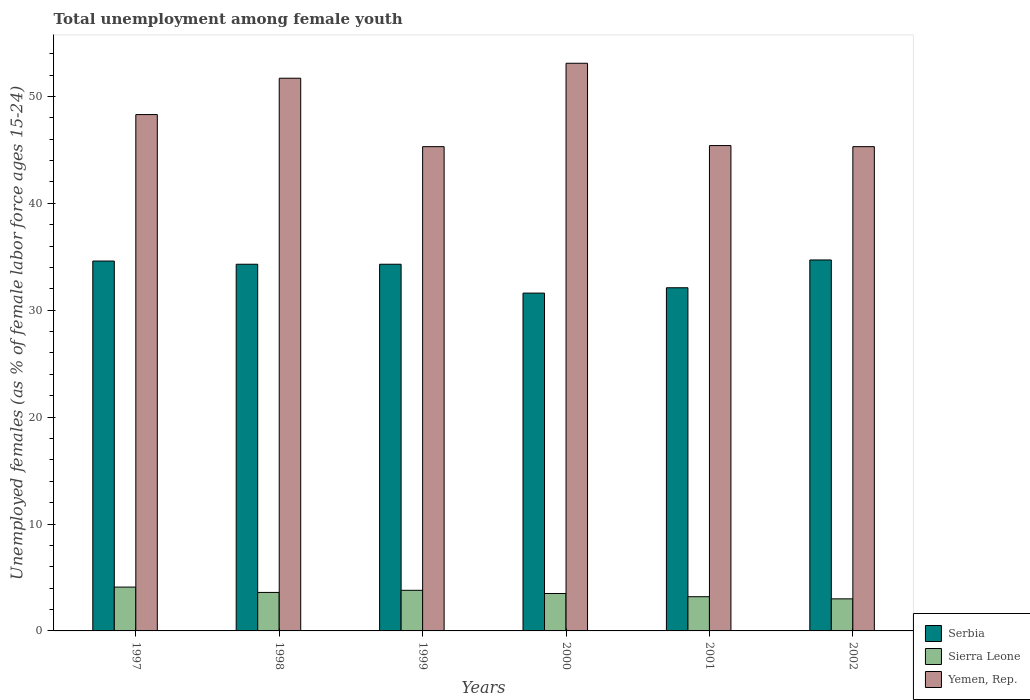Are the number of bars on each tick of the X-axis equal?
Give a very brief answer. Yes. How many bars are there on the 5th tick from the right?
Keep it short and to the point. 3. What is the label of the 5th group of bars from the left?
Make the answer very short. 2001. In how many cases, is the number of bars for a given year not equal to the number of legend labels?
Provide a succinct answer. 0. What is the percentage of unemployed females in in Sierra Leone in 2001?
Your answer should be compact. 3.2. Across all years, what is the maximum percentage of unemployed females in in Sierra Leone?
Your response must be concise. 4.1. Across all years, what is the minimum percentage of unemployed females in in Serbia?
Make the answer very short. 31.6. In which year was the percentage of unemployed females in in Serbia maximum?
Offer a very short reply. 2002. What is the total percentage of unemployed females in in Yemen, Rep. in the graph?
Give a very brief answer. 289.1. What is the difference between the percentage of unemployed females in in Sierra Leone in 1998 and that in 2000?
Offer a very short reply. 0.1. What is the difference between the percentage of unemployed females in in Serbia in 1997 and the percentage of unemployed females in in Yemen, Rep. in 1999?
Give a very brief answer. -10.7. What is the average percentage of unemployed females in in Yemen, Rep. per year?
Make the answer very short. 48.18. In the year 2002, what is the difference between the percentage of unemployed females in in Serbia and percentage of unemployed females in in Sierra Leone?
Offer a terse response. 31.7. In how many years, is the percentage of unemployed females in in Sierra Leone greater than 32 %?
Offer a terse response. 0. What is the ratio of the percentage of unemployed females in in Sierra Leone in 1997 to that in 1998?
Keep it short and to the point. 1.14. Is the difference between the percentage of unemployed females in in Serbia in 1999 and 2001 greater than the difference between the percentage of unemployed females in in Sierra Leone in 1999 and 2001?
Your answer should be very brief. Yes. What is the difference between the highest and the second highest percentage of unemployed females in in Sierra Leone?
Provide a succinct answer. 0.3. What is the difference between the highest and the lowest percentage of unemployed females in in Yemen, Rep.?
Your response must be concise. 7.8. In how many years, is the percentage of unemployed females in in Yemen, Rep. greater than the average percentage of unemployed females in in Yemen, Rep. taken over all years?
Keep it short and to the point. 3. What does the 3rd bar from the left in 2001 represents?
Make the answer very short. Yemen, Rep. What does the 2nd bar from the right in 1998 represents?
Offer a very short reply. Sierra Leone. Is it the case that in every year, the sum of the percentage of unemployed females in in Sierra Leone and percentage of unemployed females in in Serbia is greater than the percentage of unemployed females in in Yemen, Rep.?
Give a very brief answer. No. Are the values on the major ticks of Y-axis written in scientific E-notation?
Offer a terse response. No. Does the graph contain any zero values?
Make the answer very short. No. How are the legend labels stacked?
Ensure brevity in your answer.  Vertical. What is the title of the graph?
Offer a terse response. Total unemployment among female youth. Does "Tajikistan" appear as one of the legend labels in the graph?
Make the answer very short. No. What is the label or title of the X-axis?
Give a very brief answer. Years. What is the label or title of the Y-axis?
Offer a terse response. Unemployed females (as % of female labor force ages 15-24). What is the Unemployed females (as % of female labor force ages 15-24) in Serbia in 1997?
Give a very brief answer. 34.6. What is the Unemployed females (as % of female labor force ages 15-24) in Sierra Leone in 1997?
Your response must be concise. 4.1. What is the Unemployed females (as % of female labor force ages 15-24) of Yemen, Rep. in 1997?
Ensure brevity in your answer.  48.3. What is the Unemployed females (as % of female labor force ages 15-24) in Serbia in 1998?
Ensure brevity in your answer.  34.3. What is the Unemployed females (as % of female labor force ages 15-24) in Sierra Leone in 1998?
Your answer should be compact. 3.6. What is the Unemployed females (as % of female labor force ages 15-24) of Yemen, Rep. in 1998?
Provide a succinct answer. 51.7. What is the Unemployed females (as % of female labor force ages 15-24) of Serbia in 1999?
Offer a terse response. 34.3. What is the Unemployed females (as % of female labor force ages 15-24) of Sierra Leone in 1999?
Ensure brevity in your answer.  3.8. What is the Unemployed females (as % of female labor force ages 15-24) of Yemen, Rep. in 1999?
Provide a short and direct response. 45.3. What is the Unemployed females (as % of female labor force ages 15-24) of Serbia in 2000?
Make the answer very short. 31.6. What is the Unemployed females (as % of female labor force ages 15-24) in Sierra Leone in 2000?
Offer a terse response. 3.5. What is the Unemployed females (as % of female labor force ages 15-24) in Yemen, Rep. in 2000?
Offer a terse response. 53.1. What is the Unemployed females (as % of female labor force ages 15-24) in Serbia in 2001?
Give a very brief answer. 32.1. What is the Unemployed females (as % of female labor force ages 15-24) in Sierra Leone in 2001?
Keep it short and to the point. 3.2. What is the Unemployed females (as % of female labor force ages 15-24) of Yemen, Rep. in 2001?
Offer a terse response. 45.4. What is the Unemployed females (as % of female labor force ages 15-24) of Serbia in 2002?
Keep it short and to the point. 34.7. What is the Unemployed females (as % of female labor force ages 15-24) of Yemen, Rep. in 2002?
Your answer should be very brief. 45.3. Across all years, what is the maximum Unemployed females (as % of female labor force ages 15-24) in Serbia?
Offer a very short reply. 34.7. Across all years, what is the maximum Unemployed females (as % of female labor force ages 15-24) of Sierra Leone?
Offer a terse response. 4.1. Across all years, what is the maximum Unemployed females (as % of female labor force ages 15-24) in Yemen, Rep.?
Your response must be concise. 53.1. Across all years, what is the minimum Unemployed females (as % of female labor force ages 15-24) in Serbia?
Your answer should be very brief. 31.6. Across all years, what is the minimum Unemployed females (as % of female labor force ages 15-24) in Sierra Leone?
Ensure brevity in your answer.  3. Across all years, what is the minimum Unemployed females (as % of female labor force ages 15-24) in Yemen, Rep.?
Keep it short and to the point. 45.3. What is the total Unemployed females (as % of female labor force ages 15-24) in Serbia in the graph?
Ensure brevity in your answer.  201.6. What is the total Unemployed females (as % of female labor force ages 15-24) of Sierra Leone in the graph?
Your response must be concise. 21.2. What is the total Unemployed females (as % of female labor force ages 15-24) of Yemen, Rep. in the graph?
Your answer should be very brief. 289.1. What is the difference between the Unemployed females (as % of female labor force ages 15-24) of Sierra Leone in 1997 and that in 1998?
Your answer should be very brief. 0.5. What is the difference between the Unemployed females (as % of female labor force ages 15-24) in Yemen, Rep. in 1997 and that in 1998?
Give a very brief answer. -3.4. What is the difference between the Unemployed females (as % of female labor force ages 15-24) in Serbia in 1997 and that in 1999?
Provide a succinct answer. 0.3. What is the difference between the Unemployed females (as % of female labor force ages 15-24) in Sierra Leone in 1997 and that in 1999?
Make the answer very short. 0.3. What is the difference between the Unemployed females (as % of female labor force ages 15-24) of Yemen, Rep. in 1997 and that in 1999?
Provide a short and direct response. 3. What is the difference between the Unemployed females (as % of female labor force ages 15-24) of Yemen, Rep. in 1997 and that in 2000?
Your answer should be compact. -4.8. What is the difference between the Unemployed females (as % of female labor force ages 15-24) in Yemen, Rep. in 1997 and that in 2001?
Offer a very short reply. 2.9. What is the difference between the Unemployed females (as % of female labor force ages 15-24) of Serbia in 1997 and that in 2002?
Keep it short and to the point. -0.1. What is the difference between the Unemployed females (as % of female labor force ages 15-24) of Sierra Leone in 1997 and that in 2002?
Make the answer very short. 1.1. What is the difference between the Unemployed females (as % of female labor force ages 15-24) in Yemen, Rep. in 1997 and that in 2002?
Give a very brief answer. 3. What is the difference between the Unemployed females (as % of female labor force ages 15-24) of Serbia in 1998 and that in 1999?
Provide a short and direct response. 0. What is the difference between the Unemployed females (as % of female labor force ages 15-24) in Sierra Leone in 1998 and that in 1999?
Provide a succinct answer. -0.2. What is the difference between the Unemployed females (as % of female labor force ages 15-24) of Yemen, Rep. in 1998 and that in 1999?
Ensure brevity in your answer.  6.4. What is the difference between the Unemployed females (as % of female labor force ages 15-24) in Sierra Leone in 1998 and that in 2000?
Offer a terse response. 0.1. What is the difference between the Unemployed females (as % of female labor force ages 15-24) in Yemen, Rep. in 1998 and that in 2000?
Ensure brevity in your answer.  -1.4. What is the difference between the Unemployed females (as % of female labor force ages 15-24) in Serbia in 1998 and that in 2002?
Your response must be concise. -0.4. What is the difference between the Unemployed females (as % of female labor force ages 15-24) of Sierra Leone in 1999 and that in 2000?
Make the answer very short. 0.3. What is the difference between the Unemployed females (as % of female labor force ages 15-24) in Serbia in 1999 and that in 2001?
Provide a succinct answer. 2.2. What is the difference between the Unemployed females (as % of female labor force ages 15-24) of Sierra Leone in 1999 and that in 2001?
Your answer should be compact. 0.6. What is the difference between the Unemployed females (as % of female labor force ages 15-24) of Yemen, Rep. in 1999 and that in 2002?
Your answer should be compact. 0. What is the difference between the Unemployed females (as % of female labor force ages 15-24) of Sierra Leone in 2000 and that in 2001?
Provide a succinct answer. 0.3. What is the difference between the Unemployed females (as % of female labor force ages 15-24) of Yemen, Rep. in 2000 and that in 2001?
Offer a terse response. 7.7. What is the difference between the Unemployed females (as % of female labor force ages 15-24) of Yemen, Rep. in 2000 and that in 2002?
Keep it short and to the point. 7.8. What is the difference between the Unemployed females (as % of female labor force ages 15-24) in Serbia in 1997 and the Unemployed females (as % of female labor force ages 15-24) in Yemen, Rep. in 1998?
Give a very brief answer. -17.1. What is the difference between the Unemployed females (as % of female labor force ages 15-24) in Sierra Leone in 1997 and the Unemployed females (as % of female labor force ages 15-24) in Yemen, Rep. in 1998?
Your answer should be compact. -47.6. What is the difference between the Unemployed females (as % of female labor force ages 15-24) in Serbia in 1997 and the Unemployed females (as % of female labor force ages 15-24) in Sierra Leone in 1999?
Your response must be concise. 30.8. What is the difference between the Unemployed females (as % of female labor force ages 15-24) of Sierra Leone in 1997 and the Unemployed females (as % of female labor force ages 15-24) of Yemen, Rep. in 1999?
Provide a short and direct response. -41.2. What is the difference between the Unemployed females (as % of female labor force ages 15-24) of Serbia in 1997 and the Unemployed females (as % of female labor force ages 15-24) of Sierra Leone in 2000?
Your answer should be very brief. 31.1. What is the difference between the Unemployed females (as % of female labor force ages 15-24) of Serbia in 1997 and the Unemployed females (as % of female labor force ages 15-24) of Yemen, Rep. in 2000?
Offer a very short reply. -18.5. What is the difference between the Unemployed females (as % of female labor force ages 15-24) of Sierra Leone in 1997 and the Unemployed females (as % of female labor force ages 15-24) of Yemen, Rep. in 2000?
Keep it short and to the point. -49. What is the difference between the Unemployed females (as % of female labor force ages 15-24) in Serbia in 1997 and the Unemployed females (as % of female labor force ages 15-24) in Sierra Leone in 2001?
Keep it short and to the point. 31.4. What is the difference between the Unemployed females (as % of female labor force ages 15-24) in Sierra Leone in 1997 and the Unemployed females (as % of female labor force ages 15-24) in Yemen, Rep. in 2001?
Ensure brevity in your answer.  -41.3. What is the difference between the Unemployed females (as % of female labor force ages 15-24) in Serbia in 1997 and the Unemployed females (as % of female labor force ages 15-24) in Sierra Leone in 2002?
Your response must be concise. 31.6. What is the difference between the Unemployed females (as % of female labor force ages 15-24) of Sierra Leone in 1997 and the Unemployed females (as % of female labor force ages 15-24) of Yemen, Rep. in 2002?
Your answer should be compact. -41.2. What is the difference between the Unemployed females (as % of female labor force ages 15-24) of Serbia in 1998 and the Unemployed females (as % of female labor force ages 15-24) of Sierra Leone in 1999?
Your answer should be very brief. 30.5. What is the difference between the Unemployed females (as % of female labor force ages 15-24) in Serbia in 1998 and the Unemployed females (as % of female labor force ages 15-24) in Yemen, Rep. in 1999?
Your answer should be very brief. -11. What is the difference between the Unemployed females (as % of female labor force ages 15-24) of Sierra Leone in 1998 and the Unemployed females (as % of female labor force ages 15-24) of Yemen, Rep. in 1999?
Give a very brief answer. -41.7. What is the difference between the Unemployed females (as % of female labor force ages 15-24) in Serbia in 1998 and the Unemployed females (as % of female labor force ages 15-24) in Sierra Leone in 2000?
Keep it short and to the point. 30.8. What is the difference between the Unemployed females (as % of female labor force ages 15-24) in Serbia in 1998 and the Unemployed females (as % of female labor force ages 15-24) in Yemen, Rep. in 2000?
Your response must be concise. -18.8. What is the difference between the Unemployed females (as % of female labor force ages 15-24) of Sierra Leone in 1998 and the Unemployed females (as % of female labor force ages 15-24) of Yemen, Rep. in 2000?
Keep it short and to the point. -49.5. What is the difference between the Unemployed females (as % of female labor force ages 15-24) in Serbia in 1998 and the Unemployed females (as % of female labor force ages 15-24) in Sierra Leone in 2001?
Your response must be concise. 31.1. What is the difference between the Unemployed females (as % of female labor force ages 15-24) of Sierra Leone in 1998 and the Unemployed females (as % of female labor force ages 15-24) of Yemen, Rep. in 2001?
Provide a succinct answer. -41.8. What is the difference between the Unemployed females (as % of female labor force ages 15-24) of Serbia in 1998 and the Unemployed females (as % of female labor force ages 15-24) of Sierra Leone in 2002?
Offer a very short reply. 31.3. What is the difference between the Unemployed females (as % of female labor force ages 15-24) in Serbia in 1998 and the Unemployed females (as % of female labor force ages 15-24) in Yemen, Rep. in 2002?
Give a very brief answer. -11. What is the difference between the Unemployed females (as % of female labor force ages 15-24) in Sierra Leone in 1998 and the Unemployed females (as % of female labor force ages 15-24) in Yemen, Rep. in 2002?
Your answer should be compact. -41.7. What is the difference between the Unemployed females (as % of female labor force ages 15-24) of Serbia in 1999 and the Unemployed females (as % of female labor force ages 15-24) of Sierra Leone in 2000?
Provide a short and direct response. 30.8. What is the difference between the Unemployed females (as % of female labor force ages 15-24) in Serbia in 1999 and the Unemployed females (as % of female labor force ages 15-24) in Yemen, Rep. in 2000?
Provide a succinct answer. -18.8. What is the difference between the Unemployed females (as % of female labor force ages 15-24) of Sierra Leone in 1999 and the Unemployed females (as % of female labor force ages 15-24) of Yemen, Rep. in 2000?
Your response must be concise. -49.3. What is the difference between the Unemployed females (as % of female labor force ages 15-24) in Serbia in 1999 and the Unemployed females (as % of female labor force ages 15-24) in Sierra Leone in 2001?
Provide a short and direct response. 31.1. What is the difference between the Unemployed females (as % of female labor force ages 15-24) in Serbia in 1999 and the Unemployed females (as % of female labor force ages 15-24) in Yemen, Rep. in 2001?
Offer a terse response. -11.1. What is the difference between the Unemployed females (as % of female labor force ages 15-24) of Sierra Leone in 1999 and the Unemployed females (as % of female labor force ages 15-24) of Yemen, Rep. in 2001?
Give a very brief answer. -41.6. What is the difference between the Unemployed females (as % of female labor force ages 15-24) of Serbia in 1999 and the Unemployed females (as % of female labor force ages 15-24) of Sierra Leone in 2002?
Provide a short and direct response. 31.3. What is the difference between the Unemployed females (as % of female labor force ages 15-24) in Sierra Leone in 1999 and the Unemployed females (as % of female labor force ages 15-24) in Yemen, Rep. in 2002?
Ensure brevity in your answer.  -41.5. What is the difference between the Unemployed females (as % of female labor force ages 15-24) in Serbia in 2000 and the Unemployed females (as % of female labor force ages 15-24) in Sierra Leone in 2001?
Your answer should be compact. 28.4. What is the difference between the Unemployed females (as % of female labor force ages 15-24) of Serbia in 2000 and the Unemployed females (as % of female labor force ages 15-24) of Yemen, Rep. in 2001?
Your answer should be compact. -13.8. What is the difference between the Unemployed females (as % of female labor force ages 15-24) of Sierra Leone in 2000 and the Unemployed females (as % of female labor force ages 15-24) of Yemen, Rep. in 2001?
Ensure brevity in your answer.  -41.9. What is the difference between the Unemployed females (as % of female labor force ages 15-24) of Serbia in 2000 and the Unemployed females (as % of female labor force ages 15-24) of Sierra Leone in 2002?
Your answer should be very brief. 28.6. What is the difference between the Unemployed females (as % of female labor force ages 15-24) in Serbia in 2000 and the Unemployed females (as % of female labor force ages 15-24) in Yemen, Rep. in 2002?
Offer a very short reply. -13.7. What is the difference between the Unemployed females (as % of female labor force ages 15-24) of Sierra Leone in 2000 and the Unemployed females (as % of female labor force ages 15-24) of Yemen, Rep. in 2002?
Your response must be concise. -41.8. What is the difference between the Unemployed females (as % of female labor force ages 15-24) in Serbia in 2001 and the Unemployed females (as % of female labor force ages 15-24) in Sierra Leone in 2002?
Provide a succinct answer. 29.1. What is the difference between the Unemployed females (as % of female labor force ages 15-24) in Serbia in 2001 and the Unemployed females (as % of female labor force ages 15-24) in Yemen, Rep. in 2002?
Ensure brevity in your answer.  -13.2. What is the difference between the Unemployed females (as % of female labor force ages 15-24) of Sierra Leone in 2001 and the Unemployed females (as % of female labor force ages 15-24) of Yemen, Rep. in 2002?
Your answer should be compact. -42.1. What is the average Unemployed females (as % of female labor force ages 15-24) in Serbia per year?
Make the answer very short. 33.6. What is the average Unemployed females (as % of female labor force ages 15-24) in Sierra Leone per year?
Keep it short and to the point. 3.53. What is the average Unemployed females (as % of female labor force ages 15-24) of Yemen, Rep. per year?
Keep it short and to the point. 48.18. In the year 1997, what is the difference between the Unemployed females (as % of female labor force ages 15-24) of Serbia and Unemployed females (as % of female labor force ages 15-24) of Sierra Leone?
Your answer should be compact. 30.5. In the year 1997, what is the difference between the Unemployed females (as % of female labor force ages 15-24) of Serbia and Unemployed females (as % of female labor force ages 15-24) of Yemen, Rep.?
Give a very brief answer. -13.7. In the year 1997, what is the difference between the Unemployed females (as % of female labor force ages 15-24) of Sierra Leone and Unemployed females (as % of female labor force ages 15-24) of Yemen, Rep.?
Your answer should be very brief. -44.2. In the year 1998, what is the difference between the Unemployed females (as % of female labor force ages 15-24) of Serbia and Unemployed females (as % of female labor force ages 15-24) of Sierra Leone?
Offer a very short reply. 30.7. In the year 1998, what is the difference between the Unemployed females (as % of female labor force ages 15-24) in Serbia and Unemployed females (as % of female labor force ages 15-24) in Yemen, Rep.?
Your answer should be very brief. -17.4. In the year 1998, what is the difference between the Unemployed females (as % of female labor force ages 15-24) in Sierra Leone and Unemployed females (as % of female labor force ages 15-24) in Yemen, Rep.?
Give a very brief answer. -48.1. In the year 1999, what is the difference between the Unemployed females (as % of female labor force ages 15-24) of Serbia and Unemployed females (as % of female labor force ages 15-24) of Sierra Leone?
Ensure brevity in your answer.  30.5. In the year 1999, what is the difference between the Unemployed females (as % of female labor force ages 15-24) in Serbia and Unemployed females (as % of female labor force ages 15-24) in Yemen, Rep.?
Provide a succinct answer. -11. In the year 1999, what is the difference between the Unemployed females (as % of female labor force ages 15-24) in Sierra Leone and Unemployed females (as % of female labor force ages 15-24) in Yemen, Rep.?
Provide a short and direct response. -41.5. In the year 2000, what is the difference between the Unemployed females (as % of female labor force ages 15-24) in Serbia and Unemployed females (as % of female labor force ages 15-24) in Sierra Leone?
Offer a terse response. 28.1. In the year 2000, what is the difference between the Unemployed females (as % of female labor force ages 15-24) in Serbia and Unemployed females (as % of female labor force ages 15-24) in Yemen, Rep.?
Keep it short and to the point. -21.5. In the year 2000, what is the difference between the Unemployed females (as % of female labor force ages 15-24) in Sierra Leone and Unemployed females (as % of female labor force ages 15-24) in Yemen, Rep.?
Provide a short and direct response. -49.6. In the year 2001, what is the difference between the Unemployed females (as % of female labor force ages 15-24) of Serbia and Unemployed females (as % of female labor force ages 15-24) of Sierra Leone?
Make the answer very short. 28.9. In the year 2001, what is the difference between the Unemployed females (as % of female labor force ages 15-24) of Sierra Leone and Unemployed females (as % of female labor force ages 15-24) of Yemen, Rep.?
Give a very brief answer. -42.2. In the year 2002, what is the difference between the Unemployed females (as % of female labor force ages 15-24) in Serbia and Unemployed females (as % of female labor force ages 15-24) in Sierra Leone?
Provide a succinct answer. 31.7. In the year 2002, what is the difference between the Unemployed females (as % of female labor force ages 15-24) in Serbia and Unemployed females (as % of female labor force ages 15-24) in Yemen, Rep.?
Ensure brevity in your answer.  -10.6. In the year 2002, what is the difference between the Unemployed females (as % of female labor force ages 15-24) of Sierra Leone and Unemployed females (as % of female labor force ages 15-24) of Yemen, Rep.?
Give a very brief answer. -42.3. What is the ratio of the Unemployed females (as % of female labor force ages 15-24) in Serbia in 1997 to that in 1998?
Provide a succinct answer. 1.01. What is the ratio of the Unemployed females (as % of female labor force ages 15-24) in Sierra Leone in 1997 to that in 1998?
Your answer should be very brief. 1.14. What is the ratio of the Unemployed females (as % of female labor force ages 15-24) in Yemen, Rep. in 1997 to that in 1998?
Your response must be concise. 0.93. What is the ratio of the Unemployed females (as % of female labor force ages 15-24) of Serbia in 1997 to that in 1999?
Give a very brief answer. 1.01. What is the ratio of the Unemployed females (as % of female labor force ages 15-24) of Sierra Leone in 1997 to that in 1999?
Your answer should be very brief. 1.08. What is the ratio of the Unemployed females (as % of female labor force ages 15-24) in Yemen, Rep. in 1997 to that in 1999?
Your answer should be compact. 1.07. What is the ratio of the Unemployed females (as % of female labor force ages 15-24) of Serbia in 1997 to that in 2000?
Your answer should be very brief. 1.09. What is the ratio of the Unemployed females (as % of female labor force ages 15-24) of Sierra Leone in 1997 to that in 2000?
Provide a succinct answer. 1.17. What is the ratio of the Unemployed females (as % of female labor force ages 15-24) in Yemen, Rep. in 1997 to that in 2000?
Offer a very short reply. 0.91. What is the ratio of the Unemployed females (as % of female labor force ages 15-24) in Serbia in 1997 to that in 2001?
Ensure brevity in your answer.  1.08. What is the ratio of the Unemployed females (as % of female labor force ages 15-24) in Sierra Leone in 1997 to that in 2001?
Ensure brevity in your answer.  1.28. What is the ratio of the Unemployed females (as % of female labor force ages 15-24) in Yemen, Rep. in 1997 to that in 2001?
Make the answer very short. 1.06. What is the ratio of the Unemployed females (as % of female labor force ages 15-24) of Serbia in 1997 to that in 2002?
Make the answer very short. 1. What is the ratio of the Unemployed females (as % of female labor force ages 15-24) in Sierra Leone in 1997 to that in 2002?
Your response must be concise. 1.37. What is the ratio of the Unemployed females (as % of female labor force ages 15-24) in Yemen, Rep. in 1997 to that in 2002?
Your answer should be compact. 1.07. What is the ratio of the Unemployed females (as % of female labor force ages 15-24) of Serbia in 1998 to that in 1999?
Provide a succinct answer. 1. What is the ratio of the Unemployed females (as % of female labor force ages 15-24) in Yemen, Rep. in 1998 to that in 1999?
Provide a short and direct response. 1.14. What is the ratio of the Unemployed females (as % of female labor force ages 15-24) of Serbia in 1998 to that in 2000?
Your answer should be very brief. 1.09. What is the ratio of the Unemployed females (as % of female labor force ages 15-24) of Sierra Leone in 1998 to that in 2000?
Your answer should be compact. 1.03. What is the ratio of the Unemployed females (as % of female labor force ages 15-24) in Yemen, Rep. in 1998 to that in 2000?
Your response must be concise. 0.97. What is the ratio of the Unemployed females (as % of female labor force ages 15-24) in Serbia in 1998 to that in 2001?
Offer a very short reply. 1.07. What is the ratio of the Unemployed females (as % of female labor force ages 15-24) in Sierra Leone in 1998 to that in 2001?
Your answer should be very brief. 1.12. What is the ratio of the Unemployed females (as % of female labor force ages 15-24) of Yemen, Rep. in 1998 to that in 2001?
Offer a terse response. 1.14. What is the ratio of the Unemployed females (as % of female labor force ages 15-24) in Yemen, Rep. in 1998 to that in 2002?
Keep it short and to the point. 1.14. What is the ratio of the Unemployed females (as % of female labor force ages 15-24) in Serbia in 1999 to that in 2000?
Provide a succinct answer. 1.09. What is the ratio of the Unemployed females (as % of female labor force ages 15-24) of Sierra Leone in 1999 to that in 2000?
Ensure brevity in your answer.  1.09. What is the ratio of the Unemployed females (as % of female labor force ages 15-24) in Yemen, Rep. in 1999 to that in 2000?
Make the answer very short. 0.85. What is the ratio of the Unemployed females (as % of female labor force ages 15-24) in Serbia in 1999 to that in 2001?
Make the answer very short. 1.07. What is the ratio of the Unemployed females (as % of female labor force ages 15-24) of Sierra Leone in 1999 to that in 2001?
Give a very brief answer. 1.19. What is the ratio of the Unemployed females (as % of female labor force ages 15-24) in Serbia in 1999 to that in 2002?
Provide a succinct answer. 0.99. What is the ratio of the Unemployed females (as % of female labor force ages 15-24) in Sierra Leone in 1999 to that in 2002?
Make the answer very short. 1.27. What is the ratio of the Unemployed females (as % of female labor force ages 15-24) in Yemen, Rep. in 1999 to that in 2002?
Ensure brevity in your answer.  1. What is the ratio of the Unemployed females (as % of female labor force ages 15-24) in Serbia in 2000 to that in 2001?
Offer a very short reply. 0.98. What is the ratio of the Unemployed females (as % of female labor force ages 15-24) of Sierra Leone in 2000 to that in 2001?
Your response must be concise. 1.09. What is the ratio of the Unemployed females (as % of female labor force ages 15-24) of Yemen, Rep. in 2000 to that in 2001?
Provide a short and direct response. 1.17. What is the ratio of the Unemployed females (as % of female labor force ages 15-24) of Serbia in 2000 to that in 2002?
Provide a short and direct response. 0.91. What is the ratio of the Unemployed females (as % of female labor force ages 15-24) of Yemen, Rep. in 2000 to that in 2002?
Your answer should be compact. 1.17. What is the ratio of the Unemployed females (as % of female labor force ages 15-24) of Serbia in 2001 to that in 2002?
Give a very brief answer. 0.93. What is the ratio of the Unemployed females (as % of female labor force ages 15-24) of Sierra Leone in 2001 to that in 2002?
Offer a very short reply. 1.07. What is the ratio of the Unemployed females (as % of female labor force ages 15-24) of Yemen, Rep. in 2001 to that in 2002?
Provide a short and direct response. 1. What is the difference between the highest and the second highest Unemployed females (as % of female labor force ages 15-24) in Serbia?
Provide a short and direct response. 0.1. What is the difference between the highest and the second highest Unemployed females (as % of female labor force ages 15-24) in Sierra Leone?
Keep it short and to the point. 0.3. What is the difference between the highest and the lowest Unemployed females (as % of female labor force ages 15-24) in Serbia?
Ensure brevity in your answer.  3.1. What is the difference between the highest and the lowest Unemployed females (as % of female labor force ages 15-24) in Sierra Leone?
Offer a terse response. 1.1. What is the difference between the highest and the lowest Unemployed females (as % of female labor force ages 15-24) of Yemen, Rep.?
Your answer should be compact. 7.8. 